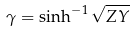<formula> <loc_0><loc_0><loc_500><loc_500>\gamma = \sinh ^ { - 1 } \sqrt { Z Y }</formula> 